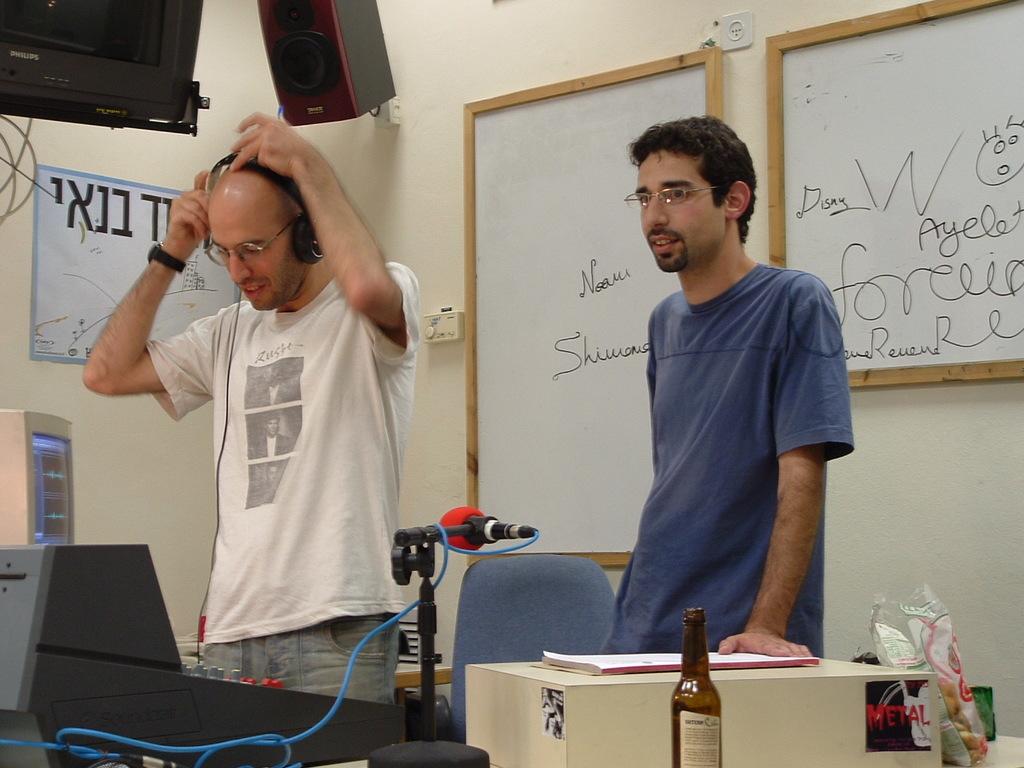What does it say on the man's white shirt?
Ensure brevity in your answer.  Unanswerable. What is written in red on the bottom right of the image?
Your response must be concise. Metal. 